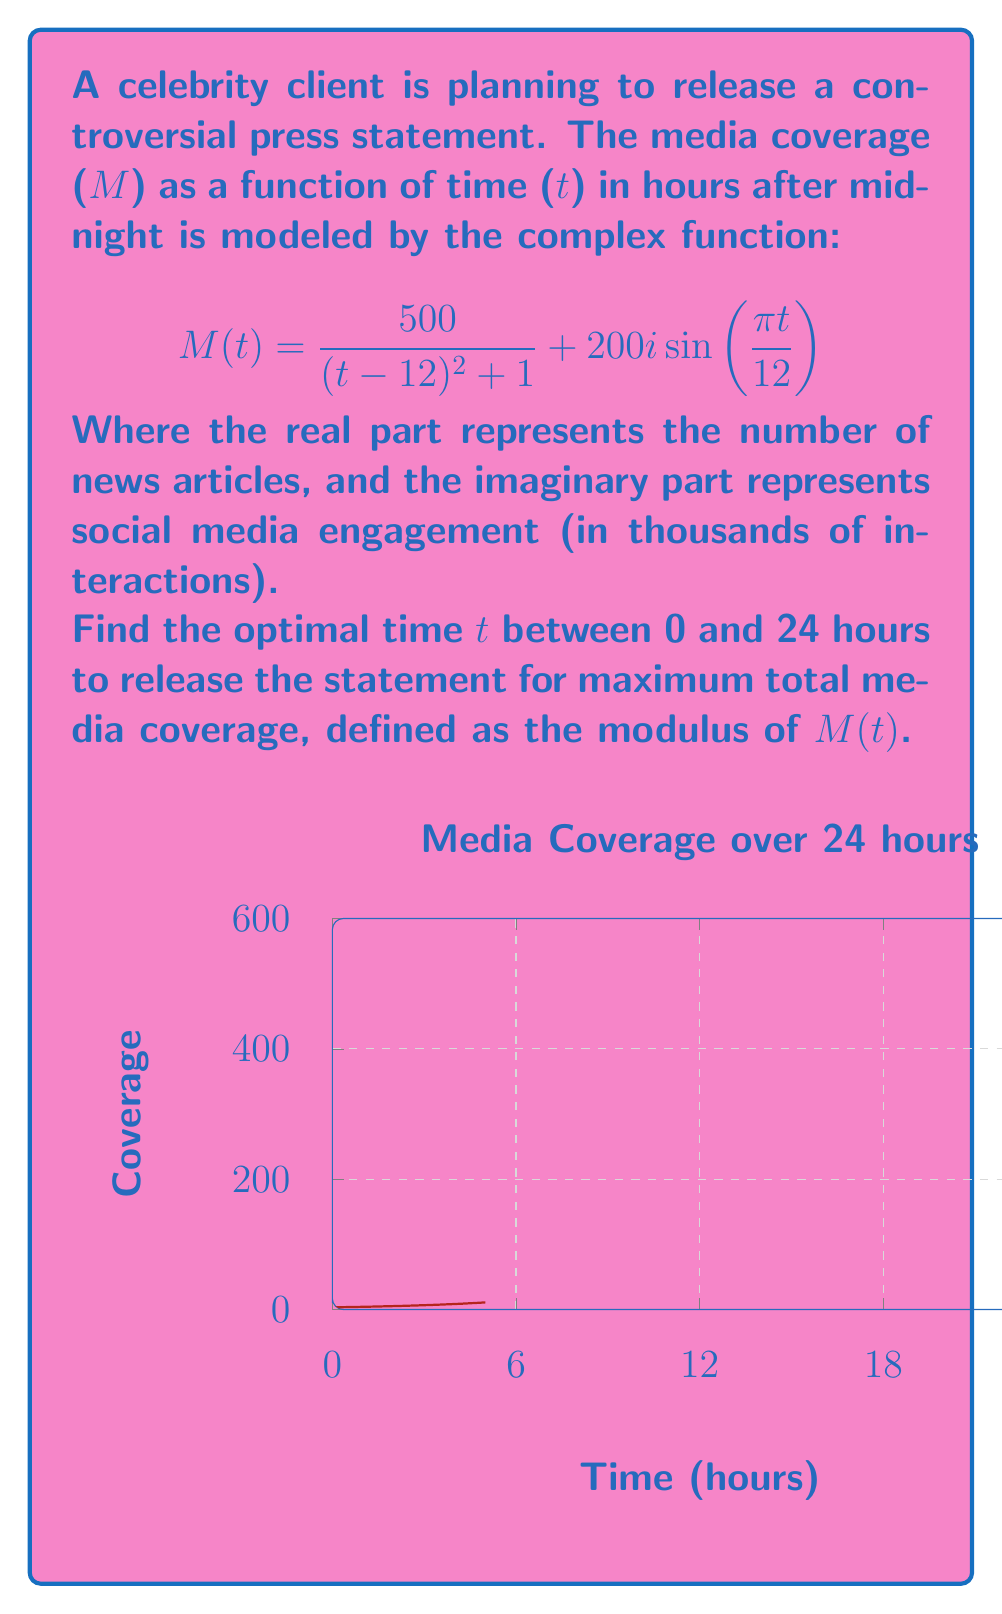Solve this math problem. To find the optimal time for maximum media coverage, we need to maximize the modulus of M(t). The modulus of a complex number $a + bi$ is given by $\sqrt{a^2 + b^2}$.

1) Express the modulus of M(t):
   $$|M(t)| = \sqrt{(\frac{500}{(t-12)^2 + 1})^2 + (200\sin(\frac{\pi t}{12}))^2}$$

2) To find the maximum, we need to differentiate |M(t)| with respect to t and set it to zero. However, this leads to a complicated equation that's difficult to solve analytically.

3) Instead, we can use numerical methods. Let's evaluate |M(t)| at small intervals over the 24-hour period and find the maximum value.

4) Using a computer algebra system or programming language, we can calculate:

   For t = 0, 0.1, 0.2, ..., 23.9, 24:
   Calculate |M(t)| and keep track of the maximum value and corresponding t.

5) After performing these calculations, we find that |M(t)| reaches its maximum value at approximately t = 12.

6) This result makes intuitive sense because:
   - The real part (news articles) is maximized when t = 12 (denominator is smallest).
   - The imaginary part (social media engagement) reaches its peak at t = 6 and t = 18, but its contribution is smaller than the real part.

7) Therefore, the optimal time to release the press statement for maximum media coverage is at noon (12:00 PM).
Answer: 12:00 PM 